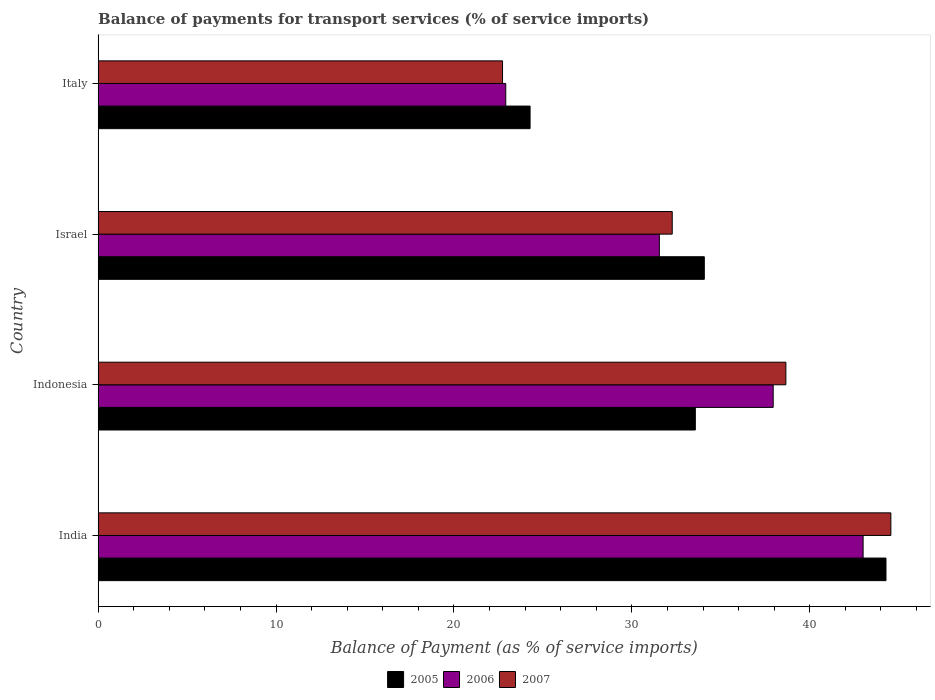How many different coloured bars are there?
Provide a short and direct response. 3. Are the number of bars on each tick of the Y-axis equal?
Make the answer very short. Yes. How many bars are there on the 3rd tick from the top?
Your answer should be compact. 3. How many bars are there on the 1st tick from the bottom?
Make the answer very short. 3. What is the label of the 3rd group of bars from the top?
Ensure brevity in your answer.  Indonesia. What is the balance of payments for transport services in 2007 in Indonesia?
Your answer should be compact. 38.66. Across all countries, what is the maximum balance of payments for transport services in 2007?
Make the answer very short. 44.56. Across all countries, what is the minimum balance of payments for transport services in 2005?
Make the answer very short. 24.28. In which country was the balance of payments for transport services in 2007 maximum?
Offer a terse response. India. In which country was the balance of payments for transport services in 2007 minimum?
Ensure brevity in your answer.  Italy. What is the total balance of payments for transport services in 2006 in the graph?
Give a very brief answer. 135.4. What is the difference between the balance of payments for transport services in 2006 in Indonesia and that in Israel?
Ensure brevity in your answer.  6.4. What is the difference between the balance of payments for transport services in 2007 in India and the balance of payments for transport services in 2005 in Indonesia?
Provide a short and direct response. 10.99. What is the average balance of payments for transport services in 2007 per country?
Keep it short and to the point. 34.55. What is the difference between the balance of payments for transport services in 2007 and balance of payments for transport services in 2005 in India?
Provide a short and direct response. 0.27. In how many countries, is the balance of payments for transport services in 2006 greater than 22 %?
Make the answer very short. 4. What is the ratio of the balance of payments for transport services in 2007 in Israel to that in Italy?
Offer a terse response. 1.42. Is the balance of payments for transport services in 2006 in India less than that in Indonesia?
Offer a very short reply. No. Is the difference between the balance of payments for transport services in 2007 in India and Italy greater than the difference between the balance of payments for transport services in 2005 in India and Italy?
Provide a succinct answer. Yes. What is the difference between the highest and the second highest balance of payments for transport services in 2007?
Give a very brief answer. 5.9. What is the difference between the highest and the lowest balance of payments for transport services in 2007?
Keep it short and to the point. 21.83. In how many countries, is the balance of payments for transport services in 2007 greater than the average balance of payments for transport services in 2007 taken over all countries?
Offer a very short reply. 2. What does the 1st bar from the top in Indonesia represents?
Make the answer very short. 2007. What does the 2nd bar from the bottom in Israel represents?
Your answer should be very brief. 2006. Is it the case that in every country, the sum of the balance of payments for transport services in 2005 and balance of payments for transport services in 2007 is greater than the balance of payments for transport services in 2006?
Your response must be concise. Yes. Are all the bars in the graph horizontal?
Give a very brief answer. Yes. What is the difference between two consecutive major ticks on the X-axis?
Your answer should be compact. 10. Does the graph contain any zero values?
Offer a terse response. No. Where does the legend appear in the graph?
Make the answer very short. Bottom center. How many legend labels are there?
Your answer should be compact. 3. How are the legend labels stacked?
Keep it short and to the point. Horizontal. What is the title of the graph?
Offer a very short reply. Balance of payments for transport services (% of service imports). What is the label or title of the X-axis?
Provide a succinct answer. Balance of Payment (as % of service imports). What is the Balance of Payment (as % of service imports) in 2005 in India?
Offer a terse response. 44.28. What is the Balance of Payment (as % of service imports) in 2006 in India?
Your answer should be compact. 43. What is the Balance of Payment (as % of service imports) in 2007 in India?
Offer a terse response. 44.56. What is the Balance of Payment (as % of service imports) of 2005 in Indonesia?
Offer a terse response. 33.57. What is the Balance of Payment (as % of service imports) of 2006 in Indonesia?
Ensure brevity in your answer.  37.94. What is the Balance of Payment (as % of service imports) of 2007 in Indonesia?
Make the answer very short. 38.66. What is the Balance of Payment (as % of service imports) in 2005 in Israel?
Offer a terse response. 34.07. What is the Balance of Payment (as % of service imports) of 2006 in Israel?
Make the answer very short. 31.55. What is the Balance of Payment (as % of service imports) in 2007 in Israel?
Your answer should be very brief. 32.27. What is the Balance of Payment (as % of service imports) in 2005 in Italy?
Provide a short and direct response. 24.28. What is the Balance of Payment (as % of service imports) of 2006 in Italy?
Provide a succinct answer. 22.91. What is the Balance of Payment (as % of service imports) in 2007 in Italy?
Your answer should be very brief. 22.73. Across all countries, what is the maximum Balance of Payment (as % of service imports) of 2005?
Your response must be concise. 44.28. Across all countries, what is the maximum Balance of Payment (as % of service imports) of 2006?
Your answer should be compact. 43. Across all countries, what is the maximum Balance of Payment (as % of service imports) in 2007?
Your answer should be very brief. 44.56. Across all countries, what is the minimum Balance of Payment (as % of service imports) of 2005?
Give a very brief answer. 24.28. Across all countries, what is the minimum Balance of Payment (as % of service imports) in 2006?
Ensure brevity in your answer.  22.91. Across all countries, what is the minimum Balance of Payment (as % of service imports) of 2007?
Ensure brevity in your answer.  22.73. What is the total Balance of Payment (as % of service imports) of 2005 in the graph?
Make the answer very short. 136.2. What is the total Balance of Payment (as % of service imports) of 2006 in the graph?
Your answer should be compact. 135.4. What is the total Balance of Payment (as % of service imports) in 2007 in the graph?
Offer a very short reply. 138.21. What is the difference between the Balance of Payment (as % of service imports) of 2005 in India and that in Indonesia?
Your answer should be very brief. 10.72. What is the difference between the Balance of Payment (as % of service imports) in 2006 in India and that in Indonesia?
Your answer should be compact. 5.05. What is the difference between the Balance of Payment (as % of service imports) of 2007 in India and that in Indonesia?
Ensure brevity in your answer.  5.9. What is the difference between the Balance of Payment (as % of service imports) of 2005 in India and that in Israel?
Provide a short and direct response. 10.21. What is the difference between the Balance of Payment (as % of service imports) of 2006 in India and that in Israel?
Offer a terse response. 11.45. What is the difference between the Balance of Payment (as % of service imports) in 2007 in India and that in Israel?
Provide a short and direct response. 12.29. What is the difference between the Balance of Payment (as % of service imports) of 2005 in India and that in Italy?
Provide a short and direct response. 20. What is the difference between the Balance of Payment (as % of service imports) in 2006 in India and that in Italy?
Your answer should be compact. 20.08. What is the difference between the Balance of Payment (as % of service imports) in 2007 in India and that in Italy?
Give a very brief answer. 21.83. What is the difference between the Balance of Payment (as % of service imports) in 2005 in Indonesia and that in Israel?
Offer a very short reply. -0.5. What is the difference between the Balance of Payment (as % of service imports) of 2006 in Indonesia and that in Israel?
Make the answer very short. 6.4. What is the difference between the Balance of Payment (as % of service imports) in 2007 in Indonesia and that in Israel?
Your response must be concise. 6.39. What is the difference between the Balance of Payment (as % of service imports) of 2005 in Indonesia and that in Italy?
Your response must be concise. 9.29. What is the difference between the Balance of Payment (as % of service imports) in 2006 in Indonesia and that in Italy?
Give a very brief answer. 15.03. What is the difference between the Balance of Payment (as % of service imports) in 2007 in Indonesia and that in Italy?
Your answer should be compact. 15.93. What is the difference between the Balance of Payment (as % of service imports) in 2005 in Israel and that in Italy?
Provide a succinct answer. 9.79. What is the difference between the Balance of Payment (as % of service imports) in 2006 in Israel and that in Italy?
Provide a succinct answer. 8.63. What is the difference between the Balance of Payment (as % of service imports) in 2007 in Israel and that in Italy?
Your response must be concise. 9.54. What is the difference between the Balance of Payment (as % of service imports) of 2005 in India and the Balance of Payment (as % of service imports) of 2006 in Indonesia?
Offer a very short reply. 6.34. What is the difference between the Balance of Payment (as % of service imports) of 2005 in India and the Balance of Payment (as % of service imports) of 2007 in Indonesia?
Keep it short and to the point. 5.63. What is the difference between the Balance of Payment (as % of service imports) of 2006 in India and the Balance of Payment (as % of service imports) of 2007 in Indonesia?
Provide a short and direct response. 4.34. What is the difference between the Balance of Payment (as % of service imports) of 2005 in India and the Balance of Payment (as % of service imports) of 2006 in Israel?
Offer a terse response. 12.74. What is the difference between the Balance of Payment (as % of service imports) of 2005 in India and the Balance of Payment (as % of service imports) of 2007 in Israel?
Your answer should be very brief. 12.01. What is the difference between the Balance of Payment (as % of service imports) in 2006 in India and the Balance of Payment (as % of service imports) in 2007 in Israel?
Ensure brevity in your answer.  10.73. What is the difference between the Balance of Payment (as % of service imports) of 2005 in India and the Balance of Payment (as % of service imports) of 2006 in Italy?
Ensure brevity in your answer.  21.37. What is the difference between the Balance of Payment (as % of service imports) in 2005 in India and the Balance of Payment (as % of service imports) in 2007 in Italy?
Provide a short and direct response. 21.55. What is the difference between the Balance of Payment (as % of service imports) of 2006 in India and the Balance of Payment (as % of service imports) of 2007 in Italy?
Your answer should be very brief. 20.27. What is the difference between the Balance of Payment (as % of service imports) in 2005 in Indonesia and the Balance of Payment (as % of service imports) in 2006 in Israel?
Provide a succinct answer. 2.02. What is the difference between the Balance of Payment (as % of service imports) of 2005 in Indonesia and the Balance of Payment (as % of service imports) of 2007 in Israel?
Provide a short and direct response. 1.3. What is the difference between the Balance of Payment (as % of service imports) of 2006 in Indonesia and the Balance of Payment (as % of service imports) of 2007 in Israel?
Your answer should be very brief. 5.67. What is the difference between the Balance of Payment (as % of service imports) of 2005 in Indonesia and the Balance of Payment (as % of service imports) of 2006 in Italy?
Give a very brief answer. 10.65. What is the difference between the Balance of Payment (as % of service imports) in 2005 in Indonesia and the Balance of Payment (as % of service imports) in 2007 in Italy?
Offer a terse response. 10.84. What is the difference between the Balance of Payment (as % of service imports) in 2006 in Indonesia and the Balance of Payment (as % of service imports) in 2007 in Italy?
Your answer should be very brief. 15.21. What is the difference between the Balance of Payment (as % of service imports) in 2005 in Israel and the Balance of Payment (as % of service imports) in 2006 in Italy?
Keep it short and to the point. 11.16. What is the difference between the Balance of Payment (as % of service imports) of 2005 in Israel and the Balance of Payment (as % of service imports) of 2007 in Italy?
Offer a terse response. 11.34. What is the difference between the Balance of Payment (as % of service imports) of 2006 in Israel and the Balance of Payment (as % of service imports) of 2007 in Italy?
Keep it short and to the point. 8.81. What is the average Balance of Payment (as % of service imports) in 2005 per country?
Offer a terse response. 34.05. What is the average Balance of Payment (as % of service imports) in 2006 per country?
Keep it short and to the point. 33.85. What is the average Balance of Payment (as % of service imports) in 2007 per country?
Keep it short and to the point. 34.55. What is the difference between the Balance of Payment (as % of service imports) of 2005 and Balance of Payment (as % of service imports) of 2006 in India?
Provide a short and direct response. 1.29. What is the difference between the Balance of Payment (as % of service imports) of 2005 and Balance of Payment (as % of service imports) of 2007 in India?
Ensure brevity in your answer.  -0.27. What is the difference between the Balance of Payment (as % of service imports) in 2006 and Balance of Payment (as % of service imports) in 2007 in India?
Offer a terse response. -1.56. What is the difference between the Balance of Payment (as % of service imports) of 2005 and Balance of Payment (as % of service imports) of 2006 in Indonesia?
Your answer should be compact. -4.38. What is the difference between the Balance of Payment (as % of service imports) of 2005 and Balance of Payment (as % of service imports) of 2007 in Indonesia?
Your answer should be very brief. -5.09. What is the difference between the Balance of Payment (as % of service imports) of 2006 and Balance of Payment (as % of service imports) of 2007 in Indonesia?
Keep it short and to the point. -0.71. What is the difference between the Balance of Payment (as % of service imports) in 2005 and Balance of Payment (as % of service imports) in 2006 in Israel?
Ensure brevity in your answer.  2.53. What is the difference between the Balance of Payment (as % of service imports) of 2005 and Balance of Payment (as % of service imports) of 2007 in Israel?
Offer a very short reply. 1.8. What is the difference between the Balance of Payment (as % of service imports) in 2006 and Balance of Payment (as % of service imports) in 2007 in Israel?
Your answer should be compact. -0.72. What is the difference between the Balance of Payment (as % of service imports) of 2005 and Balance of Payment (as % of service imports) of 2006 in Italy?
Make the answer very short. 1.37. What is the difference between the Balance of Payment (as % of service imports) in 2005 and Balance of Payment (as % of service imports) in 2007 in Italy?
Provide a short and direct response. 1.55. What is the difference between the Balance of Payment (as % of service imports) of 2006 and Balance of Payment (as % of service imports) of 2007 in Italy?
Give a very brief answer. 0.18. What is the ratio of the Balance of Payment (as % of service imports) of 2005 in India to that in Indonesia?
Your answer should be compact. 1.32. What is the ratio of the Balance of Payment (as % of service imports) of 2006 in India to that in Indonesia?
Offer a terse response. 1.13. What is the ratio of the Balance of Payment (as % of service imports) in 2007 in India to that in Indonesia?
Your answer should be compact. 1.15. What is the ratio of the Balance of Payment (as % of service imports) of 2005 in India to that in Israel?
Offer a very short reply. 1.3. What is the ratio of the Balance of Payment (as % of service imports) in 2006 in India to that in Israel?
Provide a short and direct response. 1.36. What is the ratio of the Balance of Payment (as % of service imports) in 2007 in India to that in Israel?
Your answer should be compact. 1.38. What is the ratio of the Balance of Payment (as % of service imports) of 2005 in India to that in Italy?
Make the answer very short. 1.82. What is the ratio of the Balance of Payment (as % of service imports) of 2006 in India to that in Italy?
Your answer should be compact. 1.88. What is the ratio of the Balance of Payment (as % of service imports) in 2007 in India to that in Italy?
Make the answer very short. 1.96. What is the ratio of the Balance of Payment (as % of service imports) of 2005 in Indonesia to that in Israel?
Ensure brevity in your answer.  0.99. What is the ratio of the Balance of Payment (as % of service imports) of 2006 in Indonesia to that in Israel?
Provide a succinct answer. 1.2. What is the ratio of the Balance of Payment (as % of service imports) of 2007 in Indonesia to that in Israel?
Offer a very short reply. 1.2. What is the ratio of the Balance of Payment (as % of service imports) of 2005 in Indonesia to that in Italy?
Provide a short and direct response. 1.38. What is the ratio of the Balance of Payment (as % of service imports) in 2006 in Indonesia to that in Italy?
Your answer should be compact. 1.66. What is the ratio of the Balance of Payment (as % of service imports) in 2007 in Indonesia to that in Italy?
Provide a short and direct response. 1.7. What is the ratio of the Balance of Payment (as % of service imports) in 2005 in Israel to that in Italy?
Offer a terse response. 1.4. What is the ratio of the Balance of Payment (as % of service imports) of 2006 in Israel to that in Italy?
Make the answer very short. 1.38. What is the ratio of the Balance of Payment (as % of service imports) of 2007 in Israel to that in Italy?
Give a very brief answer. 1.42. What is the difference between the highest and the second highest Balance of Payment (as % of service imports) of 2005?
Make the answer very short. 10.21. What is the difference between the highest and the second highest Balance of Payment (as % of service imports) in 2006?
Make the answer very short. 5.05. What is the difference between the highest and the second highest Balance of Payment (as % of service imports) of 2007?
Offer a very short reply. 5.9. What is the difference between the highest and the lowest Balance of Payment (as % of service imports) in 2005?
Ensure brevity in your answer.  20. What is the difference between the highest and the lowest Balance of Payment (as % of service imports) of 2006?
Offer a terse response. 20.08. What is the difference between the highest and the lowest Balance of Payment (as % of service imports) in 2007?
Your answer should be very brief. 21.83. 